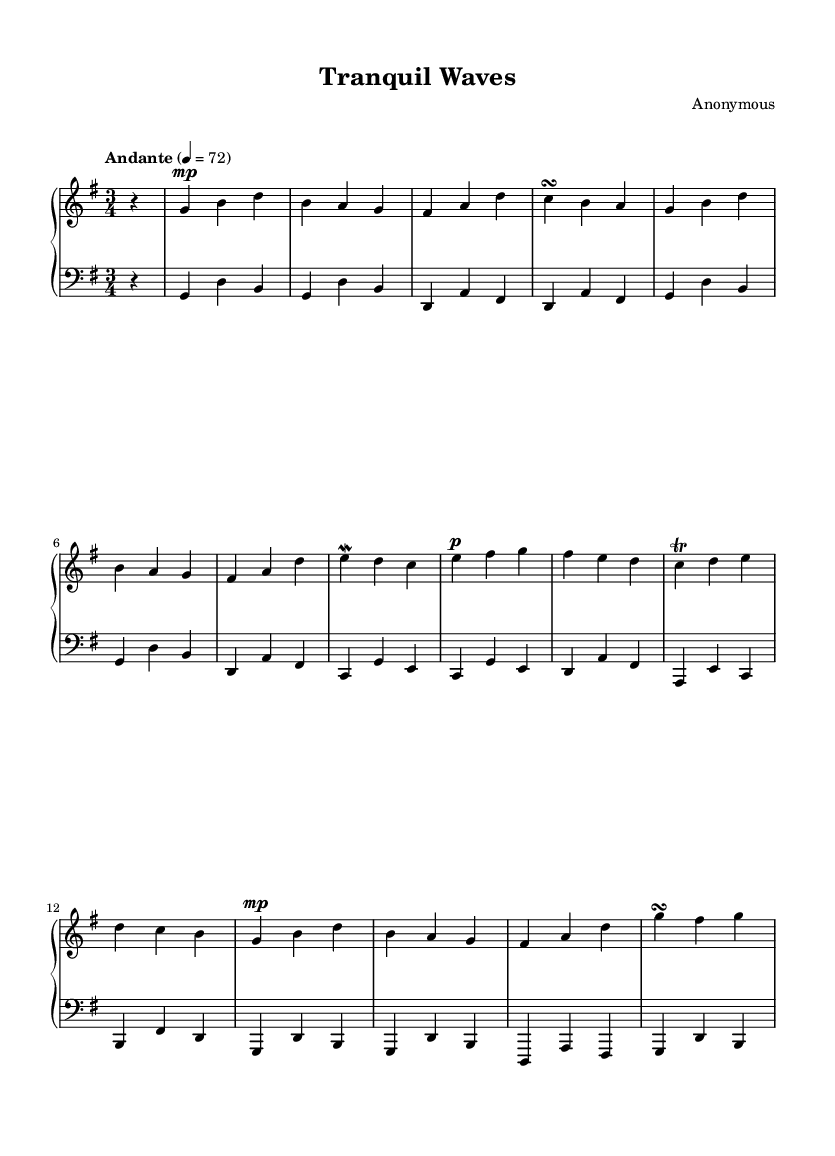What is the key signature of this music? The key signature is G major, which includes one sharp (F#).
Answer: G major What is the time signature of this piece? The time signature is three beats per measure, indicated by the "3/4" notation at the beginning.
Answer: 3/4 What is the tempo marking for this piece? The tempo marking is "Andante," which suggests a moderately slow pace, typically around 76-108 beats per minute.
Answer: Andante How many measures are present in the right-hand part? By counting the distinct sections of music, there are a total of 8 measures in the right-hand part.
Answer: 8 What is the dynamic marking of the first measure in the right hand? The first measure features a "piano" dynamic marking, which indicates playing softly.
Answer: piano Which ornaments are used in this piece? The piece includes a mordent and a trill, specifically found in the third and fourth measures of the right hand.
Answer: mordent and trill What is the main theme or mood conveyed by the music? The overall mood of the piece is soothing and tranquil, reflecting its calming nature and purpose for relaxation.
Answer: soothing and tranquil 